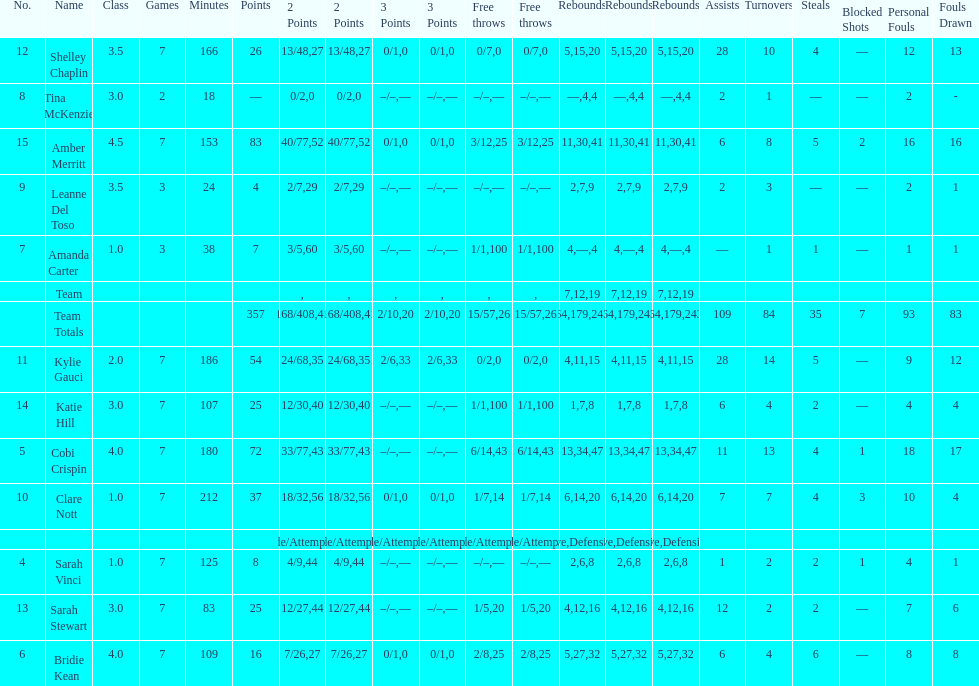Next to merritt, who was the top scorer? Cobi Crispin. 